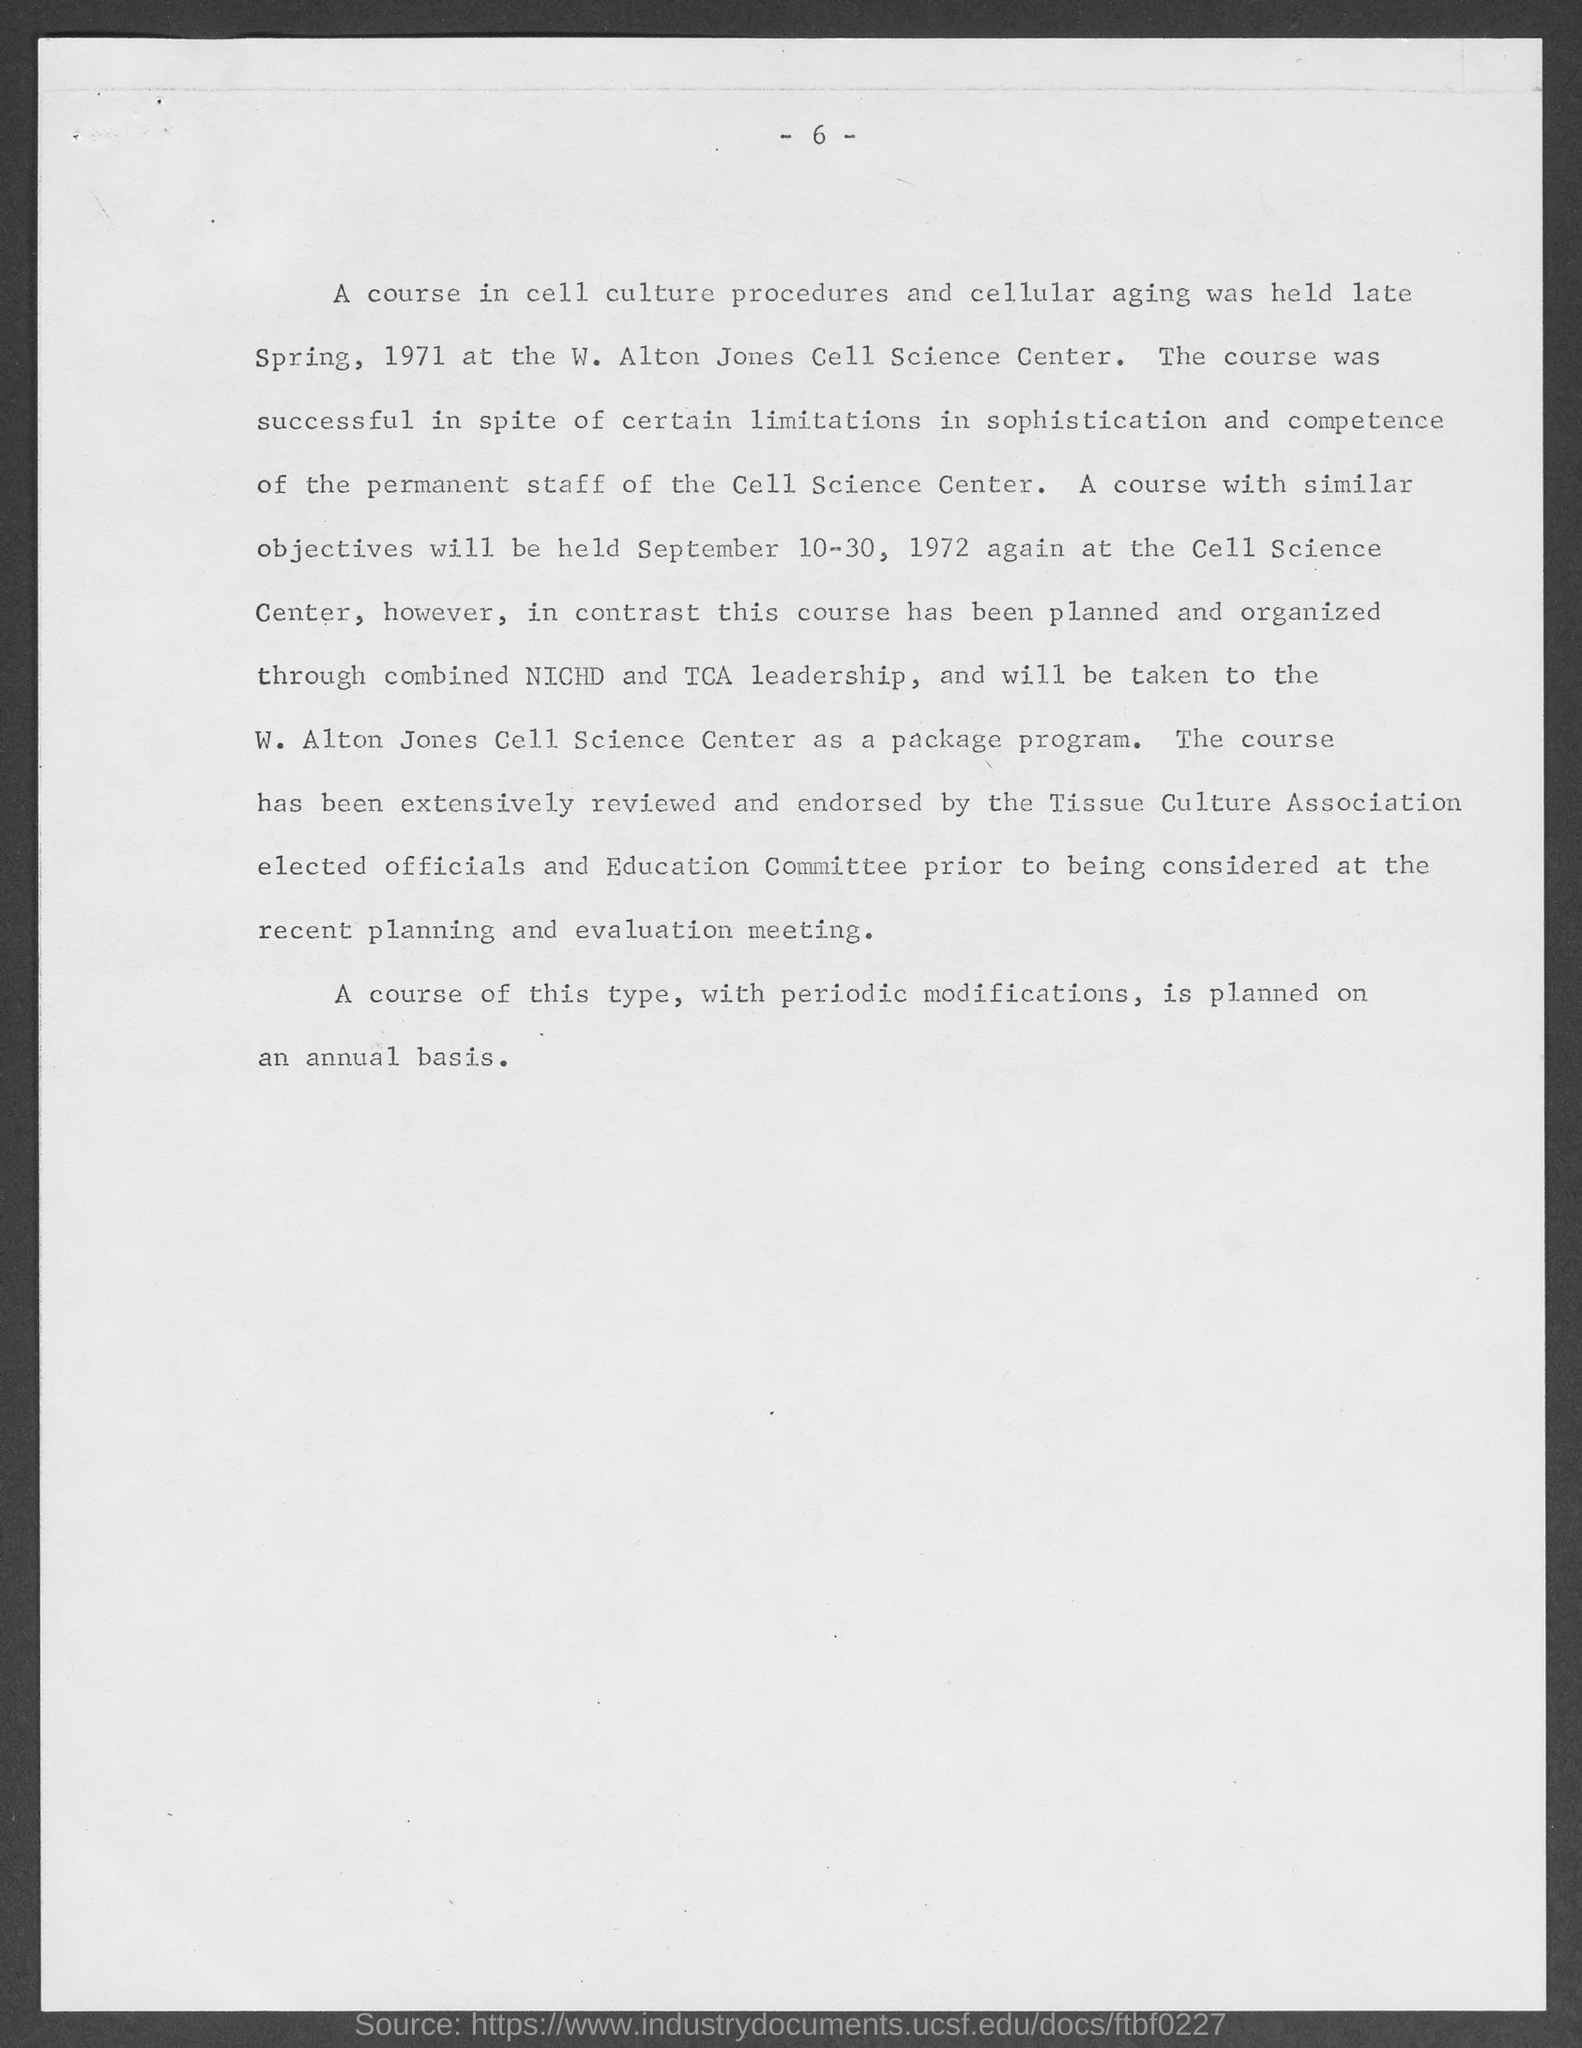What is the page no mentioned in this document?
Offer a very short reply. -6-. 